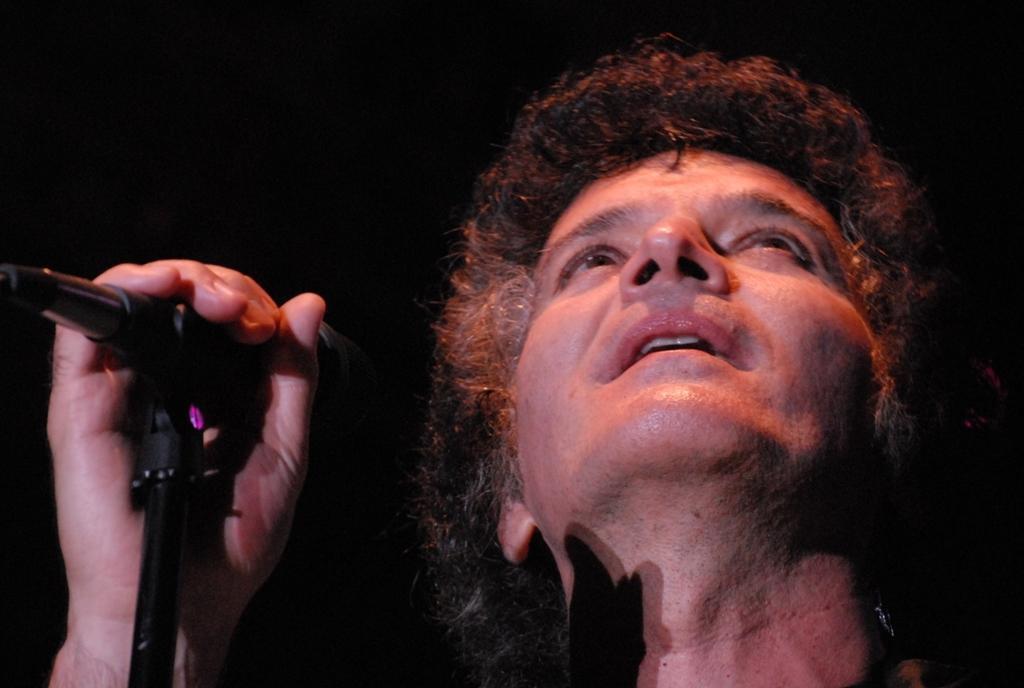In one or two sentences, can you explain what this image depicts? A person is holding mic in his hand and looking up. 